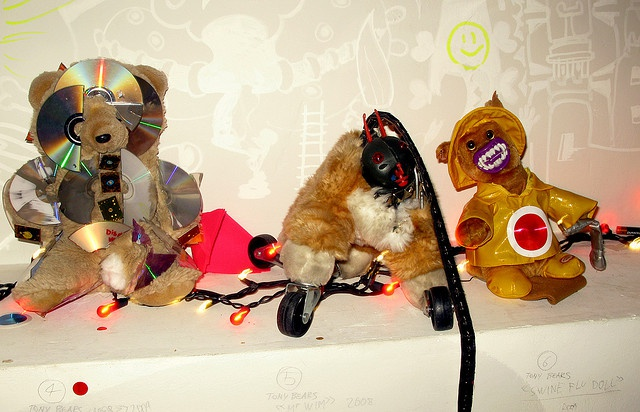Describe the objects in this image and their specific colors. I can see teddy bear in tan, gray, black, and olive tones, teddy bear in tan, olive, and black tones, and teddy bear in tan, olive, maroon, and orange tones in this image. 